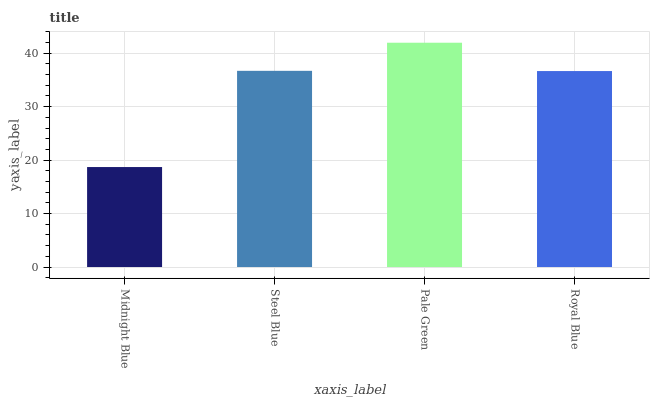Is Midnight Blue the minimum?
Answer yes or no. Yes. Is Pale Green the maximum?
Answer yes or no. Yes. Is Steel Blue the minimum?
Answer yes or no. No. Is Steel Blue the maximum?
Answer yes or no. No. Is Steel Blue greater than Midnight Blue?
Answer yes or no. Yes. Is Midnight Blue less than Steel Blue?
Answer yes or no. Yes. Is Midnight Blue greater than Steel Blue?
Answer yes or no. No. Is Steel Blue less than Midnight Blue?
Answer yes or no. No. Is Steel Blue the high median?
Answer yes or no. Yes. Is Royal Blue the low median?
Answer yes or no. Yes. Is Royal Blue the high median?
Answer yes or no. No. Is Pale Green the low median?
Answer yes or no. No. 